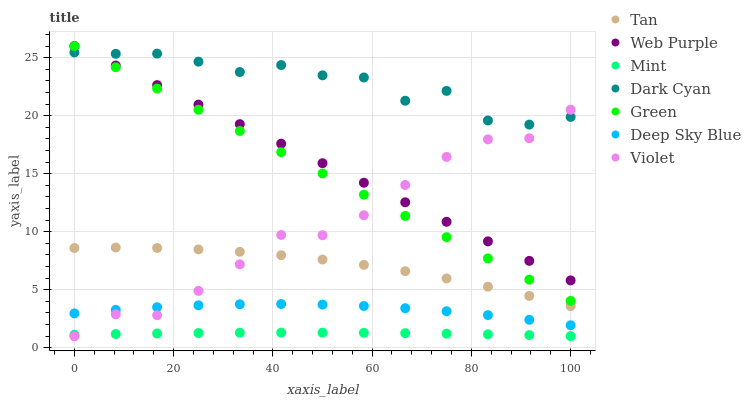Does Mint have the minimum area under the curve?
Answer yes or no. Yes. Does Dark Cyan have the maximum area under the curve?
Answer yes or no. Yes. Does Green have the minimum area under the curve?
Answer yes or no. No. Does Green have the maximum area under the curve?
Answer yes or no. No. Is Green the smoothest?
Answer yes or no. Yes. Is Dark Cyan the roughest?
Answer yes or no. Yes. Is Deep Sky Blue the smoothest?
Answer yes or no. No. Is Deep Sky Blue the roughest?
Answer yes or no. No. Does Violet have the lowest value?
Answer yes or no. Yes. Does Green have the lowest value?
Answer yes or no. No. Does Green have the highest value?
Answer yes or no. Yes. Does Deep Sky Blue have the highest value?
Answer yes or no. No. Is Mint less than Dark Cyan?
Answer yes or no. Yes. Is Dark Cyan greater than Mint?
Answer yes or no. Yes. Does Dark Cyan intersect Green?
Answer yes or no. Yes. Is Dark Cyan less than Green?
Answer yes or no. No. Is Dark Cyan greater than Green?
Answer yes or no. No. Does Mint intersect Dark Cyan?
Answer yes or no. No. 